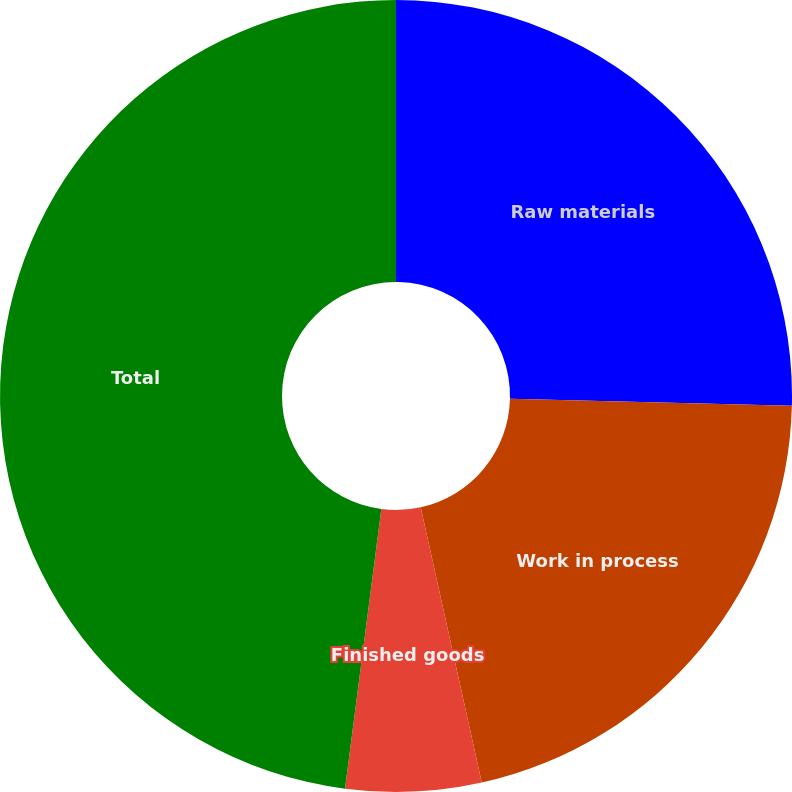Convert chart to OTSL. <chart><loc_0><loc_0><loc_500><loc_500><pie_chart><fcel>Raw materials<fcel>Work in process<fcel>Finished goods<fcel>Total<nl><fcel>25.39%<fcel>21.14%<fcel>5.53%<fcel>47.95%<nl></chart> 